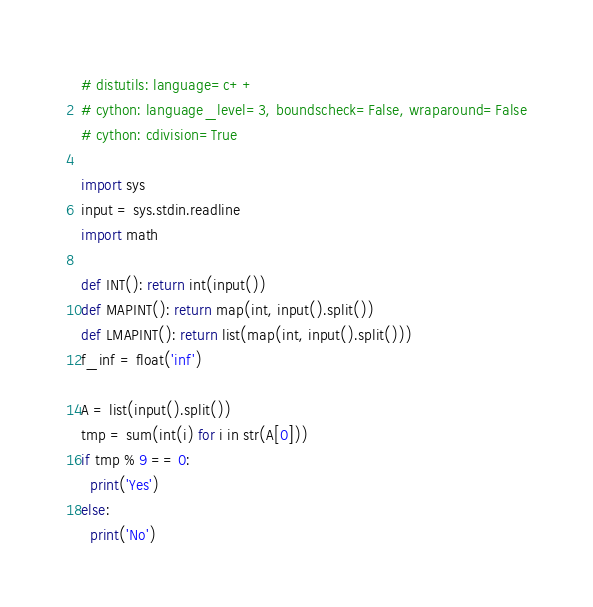Convert code to text. <code><loc_0><loc_0><loc_500><loc_500><_Cython_># distutils: language=c++
# cython: language_level=3, boundscheck=False, wraparound=False
# cython: cdivision=True

import sys
input = sys.stdin.readline
import math

def INT(): return int(input())
def MAPINT(): return map(int, input().split())
def LMAPINT(): return list(map(int, input().split()))
f_inf = float('inf')

A = list(input().split())
tmp = sum(int(i) for i in str(A[0]))
if tmp % 9 == 0:
  print('Yes')
else:
  print('No')</code> 